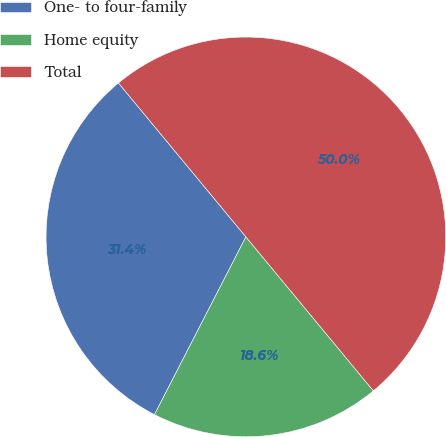<chart> <loc_0><loc_0><loc_500><loc_500><pie_chart><fcel>One- to four-family<fcel>Home equity<fcel>Total<nl><fcel>31.43%<fcel>18.57%<fcel>50.0%<nl></chart> 